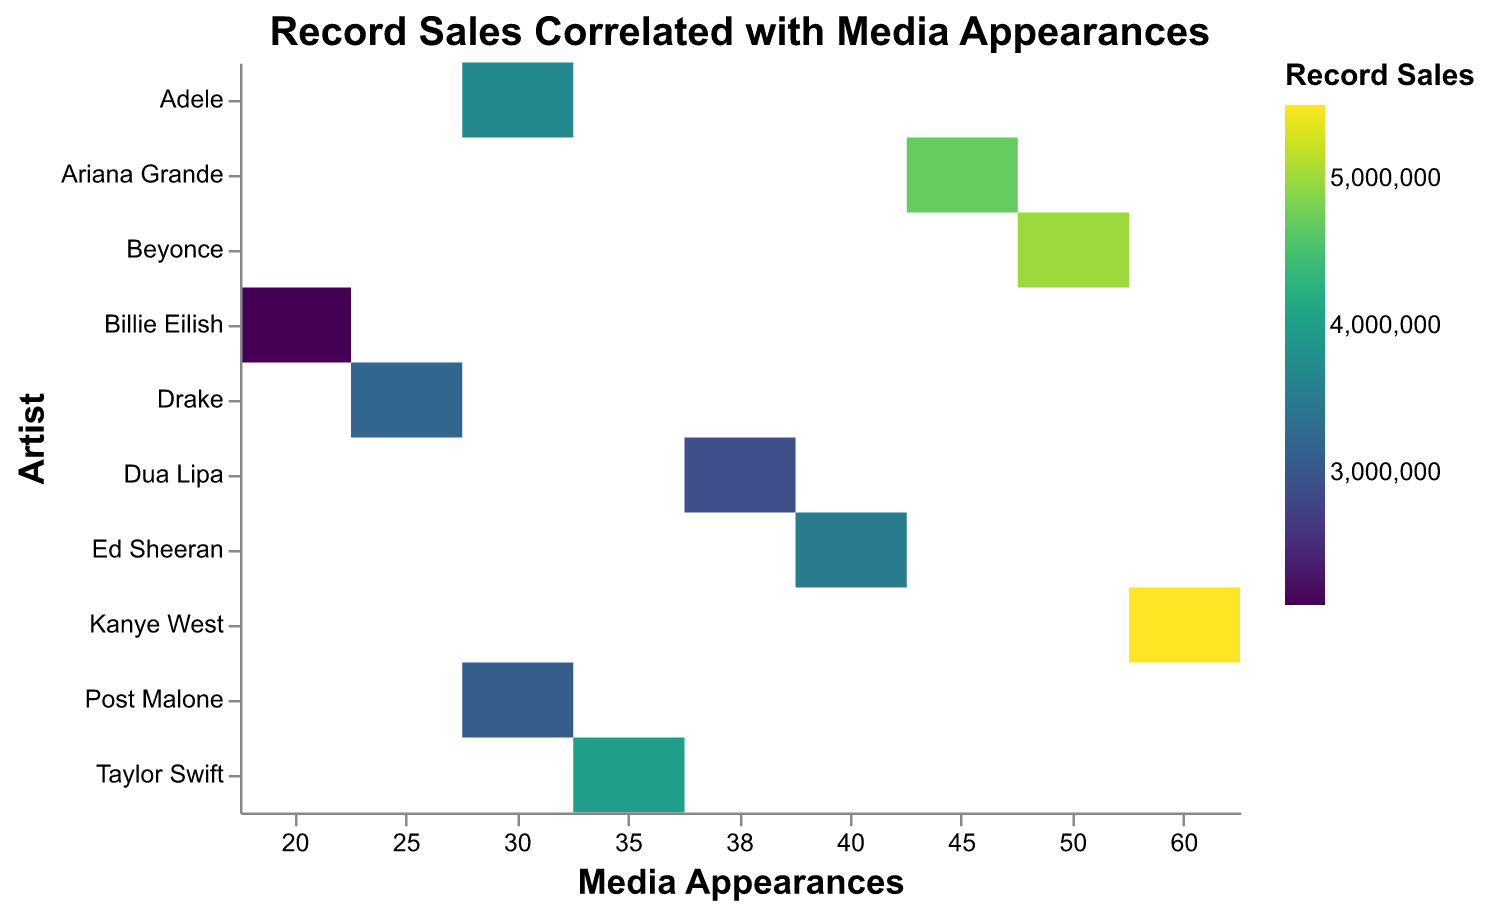What is the title of the heatmap? The title of the heatmap is displayed at the top and centers on the figure. It typically summarizes the primary focus of the visual representation.
Answer: Record Sales Correlated with Media Appearances Which artist has the highest record sales according to the heatmap? By looking at the color intensity, the artist associated with the darkest color represents the highest record sales.
Answer: Kanye West How many media appearances did Taylor Swift make? Taylor Swift's media appearances can be determined by locating her row and counting the data point on the x-axis.
Answer: 35 Compare the record sales between Ed Sheeran and Post Malone. Who has higher sales? To compare, find the colors corresponding to Ed Sheeran and Post Malone, and the darker color represents higher sales.
Answer: Ed Sheeran What is the total number of publicity events attended by Adele and Billie Eilish? Sum the provided values for publicity events for both artists: Adele (40) and Billie Eilish (25). Hence, 40 + 25.
Answer: 65 Which artist participated in the most media appearances? Locate the artist with the highest value on the x-axis.
Answer: Kanye West Do more media appearances generally correlate with higher record sales? Observing the trend in the heatmap, where higher numbers on the x-axis are associated with darker colors, suggests a correlation.
Answer: Yes How many artists have more than 40 media appearances? Count the number of artists whose media appearances value is greater than 40.
Answer: 4 What are the record sales for artists with 30 media appearances? Locate the artists with 30 media appearances and note their corresponding record sales.
Answer: Adele: 3700000, Post Malone: 3100000 Which has a stronger impact on record sales according to the heatmap: media appearances or publicity events? By comparing both axes, determine which is more consistently associated with darker cell colors representing higher sales.
Answer: Media appearances 